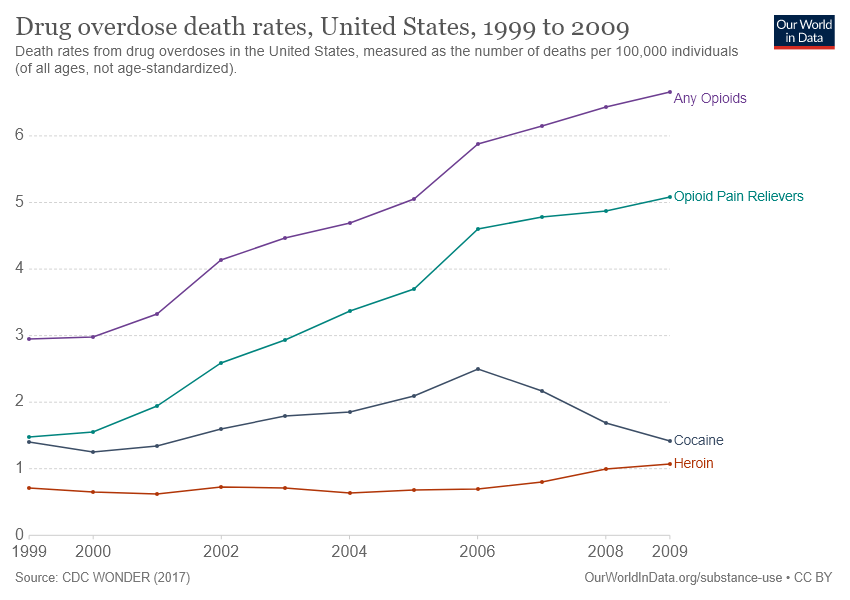Outline some significant characteristics in this image. Opioids have been recorded to have the highest number of deaths due to drug overdose in the United States over the years. In 2009, the death rate due to the consumption of heroin was at its highest. 